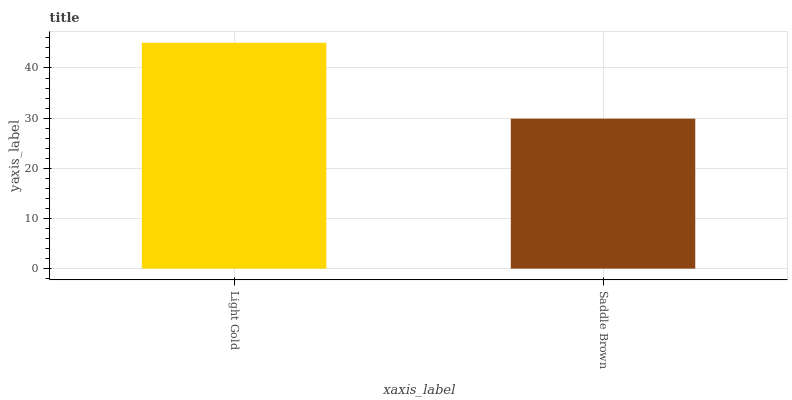Is Saddle Brown the minimum?
Answer yes or no. Yes. Is Light Gold the maximum?
Answer yes or no. Yes. Is Saddle Brown the maximum?
Answer yes or no. No. Is Light Gold greater than Saddle Brown?
Answer yes or no. Yes. Is Saddle Brown less than Light Gold?
Answer yes or no. Yes. Is Saddle Brown greater than Light Gold?
Answer yes or no. No. Is Light Gold less than Saddle Brown?
Answer yes or no. No. Is Light Gold the high median?
Answer yes or no. Yes. Is Saddle Brown the low median?
Answer yes or no. Yes. Is Saddle Brown the high median?
Answer yes or no. No. Is Light Gold the low median?
Answer yes or no. No. 